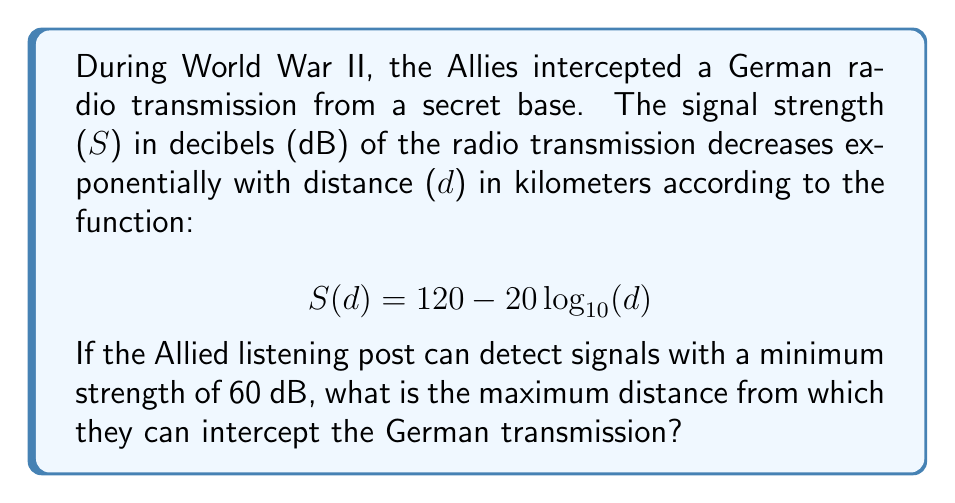Can you solve this math problem? To solve this problem, we need to use the given exponential function and find the distance at which the signal strength equals 60 dB. Let's approach this step-by-step:

1) We start with the equation:
   $$ S(d) = 120 - 20 \log_{10}(d) $$

2) We want to find d when S(d) = 60. So, let's substitute this:
   $$ 60 = 120 - 20 \log_{10}(d) $$

3) Subtract 120 from both sides:
   $$ -60 = -20 \log_{10}(d) $$

4) Divide both sides by -20:
   $$ 3 = \log_{10}(d) $$

5) To solve for d, we need to apply the inverse function of $\log_{10}$, which is $10^x$:
   $$ d = 10^3 $$

6) Calculate the result:
   $$ d = 1000 $$

Therefore, the maximum distance from which the Allies can intercept the German transmission is 1000 kilometers.
Answer: The maximum distance from which the Allies can intercept the German transmission is 1000 km. 